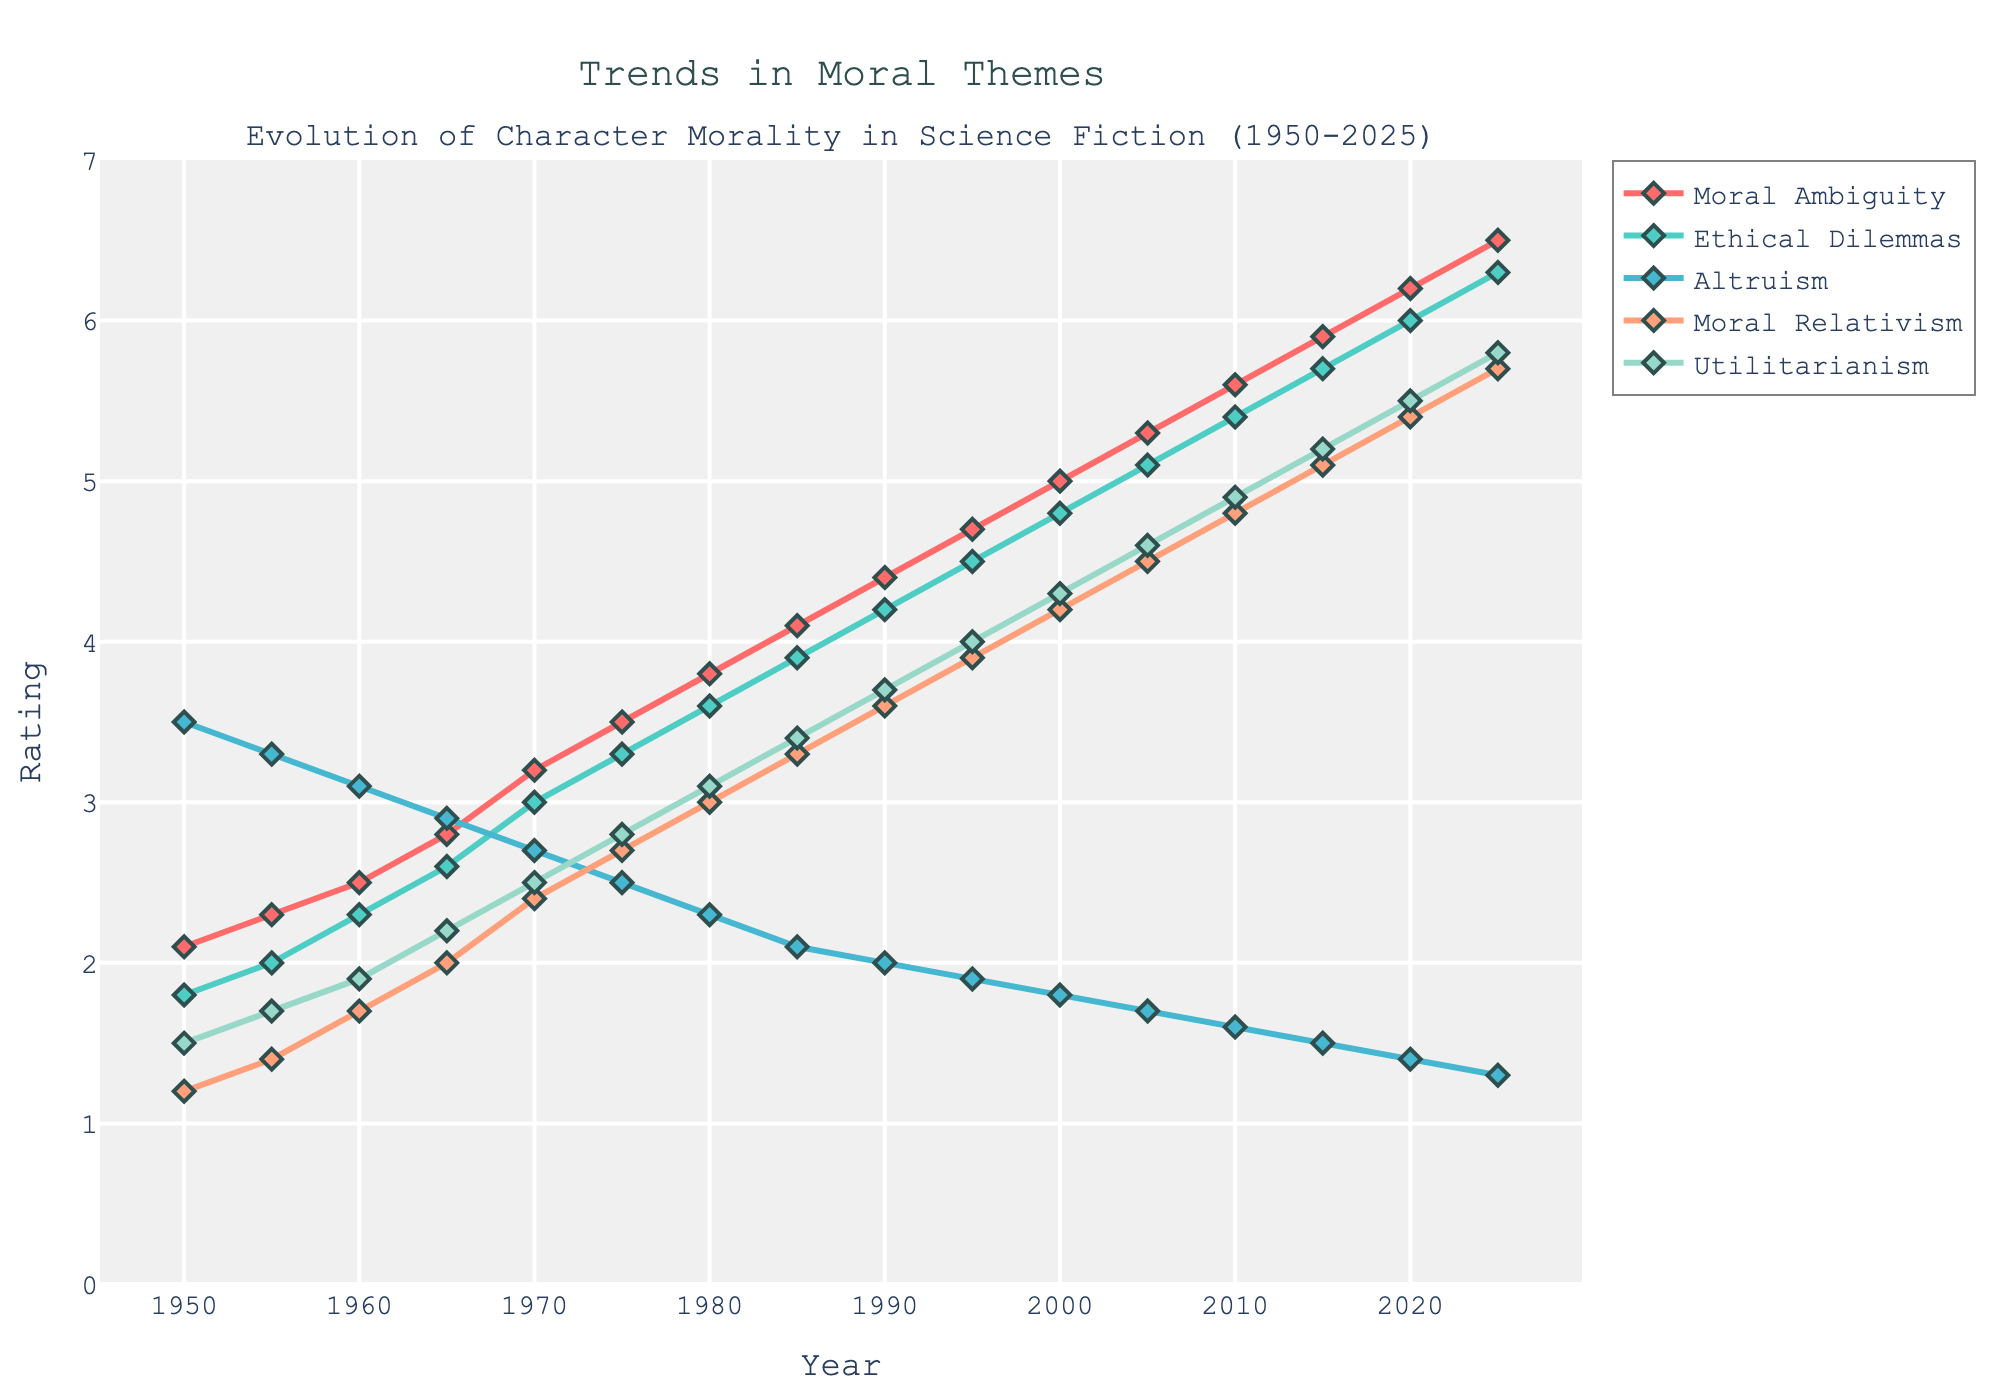What is the overall trend of the 'Moral Ambiguity' rating from 1950 to 2025? The 'Moral Ambiguity' rating shows a consistent upward trend from 2.1 in 1950 to 6.5 in 2025. This indicates that characters in science fiction works have become increasingly morally ambiguous over the years.
Answer: Upward How does the 'Altruism' rating in 1950 compare to the 'Altruism' rating in 2025? In 1950, the 'Altruism' rating was 3.5, whereas in 2025, it dropped to 1.3. This shows a significant decline in altruistic behavior depicted in science fiction characters over the years.
Answer: Decline Between which years did the 'Ethical Dilemmas' rating rise the most sharply? The 'Ethical Dilemmas' rating experienced the sharpest rise between 1950 and 2025, from 1.8 to 6.3. The increase is more pronounced in the latter half of the dataset, particularly from 2000 to 2005, where it rose from 4.8 to 5.1.
Answer: 2000 to 2005 By how much did the 'Utilitarianism' rating increase from 1960 to 2020? The 'Utilitarianism' rating increased from 1.9 in 1960 to 5.5 in 2020. The amount of increase is 5.5 - 1.9 = 3.6.
Answer: 3.6 Which moral aspect had the highest rating in 1950, and what was the rating? In 1950, 'Altruism' had the highest rating among the different moral aspects, with a rating of 3.5.
Answer: Altruism; 3.5 In what year did 'Moral Relativism' first surpass a rating of 3? 'Moral Relativism' first surpassed a rating of 3 in 1980, reaching a value of 3.0 exactly and then further increasing in subsequent years.
Answer: 1980 Compare the ratings of 'Moral Ambiguity' and 'Utilitarianism' in 1995. Which one is higher and by how much? In 1995, 'Moral Ambiguity' had a rating of 4.7, while 'Utilitarianism' had a rating of 4.0. 'Moral Ambiguity' is higher by 4.7 - 4.0 = 0.7.
Answer: Moral Ambiguity by 0.7 What is the average rating of 'Ethical Dilemmas' over the period 1950 to 2025? To find the average rating of 'Ethical Dilemmas', sum all the ratings from 1950 to 2025 (1.8 + 2.0 + 2.3 + 2.6 + 3.0 + 3.3 + 3.6 + 3.9 + 4.2 + 4.5 + 4.8 + 5.1 + 5.4 + 5.7 + 6.0 + 6.3 = 65.3) and divide by the number of data points (16). The average is 65.3 / 16 = 4.08.
Answer: 4.08 By how much did the 'Altruism' rating change from 1950 to 1970, and what does this suggest? From 1950 to 1970, the 'Altruism' rating decreased from 3.5 to 2.7, a change of 3.5 - 2.7 = 0.8. This suggests a decreasing trend in altruistic behavior in science fiction characters during this period.
Answer: Decreased by 0.8 What's the difference between the ratings of 'Moral Relativism' and 'Altruism' in 1980? In 1980, 'Moral Relativism' had a rating of 3.0, while 'Altruism' had a rating of 2.3. The difference is 3.0 - 2.3 = 0.7.
Answer: 0.7 